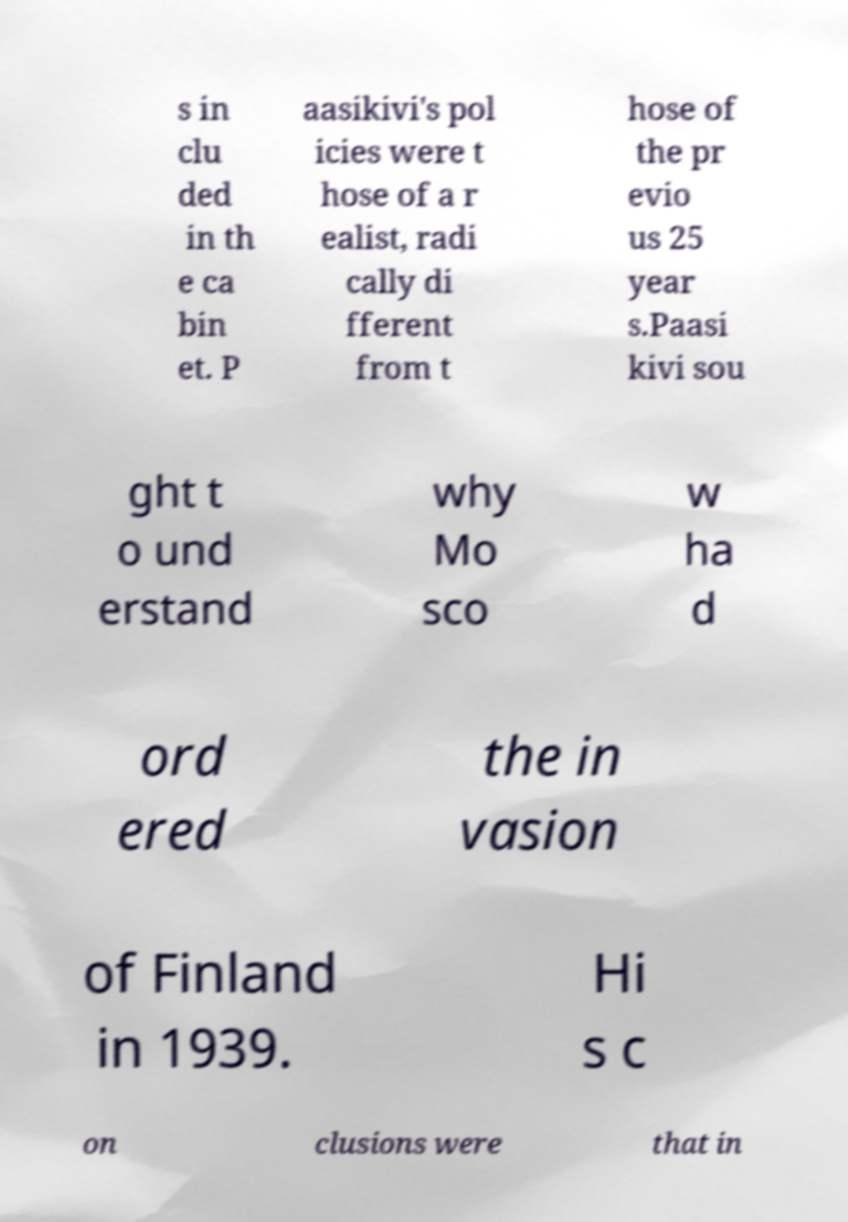Please read and relay the text visible in this image. What does it say? s in clu ded in th e ca bin et. P aasikivi's pol icies were t hose of a r ealist, radi cally di fferent from t hose of the pr evio us 25 year s.Paasi kivi sou ght t o und erstand why Mo sco w ha d ord ered the in vasion of Finland in 1939. Hi s c on clusions were that in 